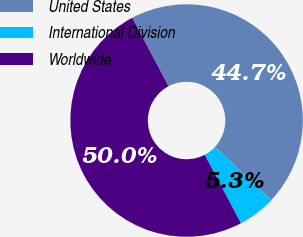Convert chart to OTSL. <chart><loc_0><loc_0><loc_500><loc_500><pie_chart><fcel>United States<fcel>International Division<fcel>Worldwide<nl><fcel>44.73%<fcel>5.27%<fcel>50.0%<nl></chart> 